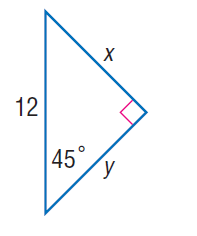Answer the mathemtical geometry problem and directly provide the correct option letter.
Question: Find x.
Choices: A: 2 \sqrt { 2 } B: 3 \sqrt { 2 } C: 5 \sqrt { 2 } D: 6 \sqrt { 2 } D 